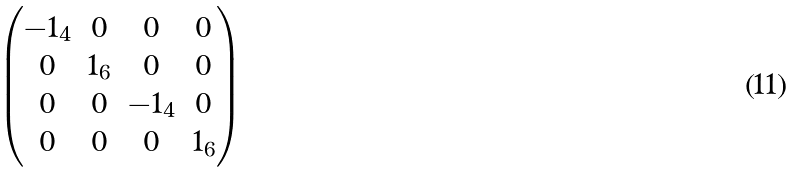<formula> <loc_0><loc_0><loc_500><loc_500>\begin{pmatrix} - 1 _ { 4 } & 0 & 0 & 0 \\ 0 & 1 _ { 6 } & 0 & 0 \\ 0 & 0 & - 1 _ { 4 } & 0 \\ 0 & 0 & 0 & 1 _ { 6 } \end{pmatrix}</formula> 